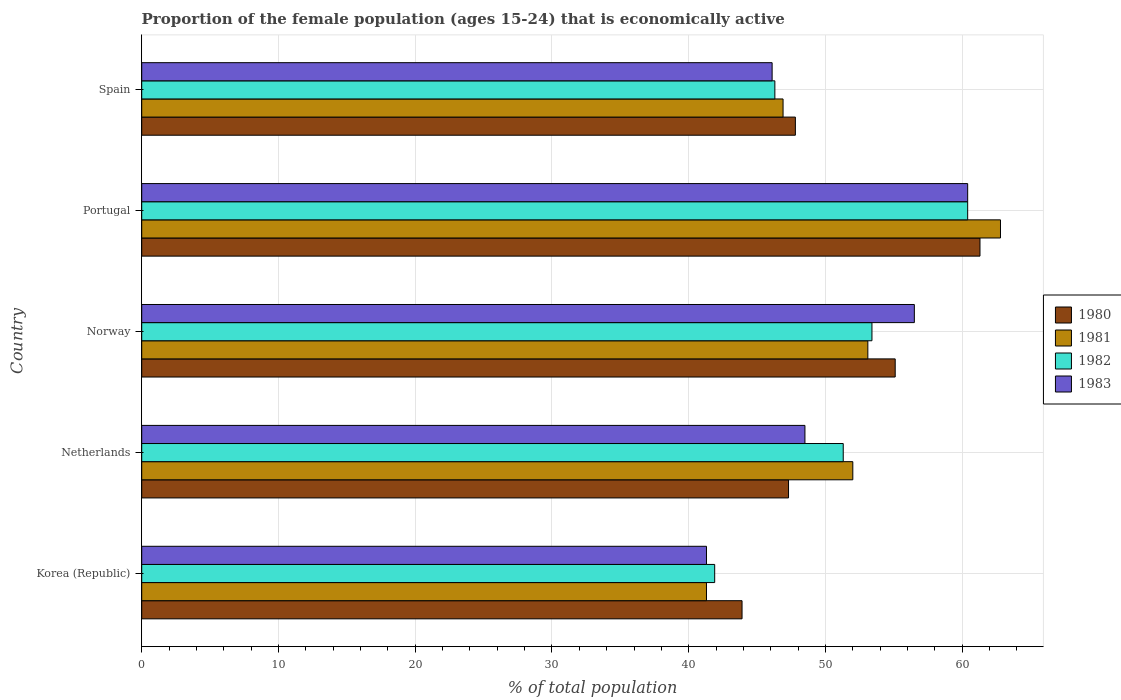How many different coloured bars are there?
Provide a short and direct response. 4. How many groups of bars are there?
Make the answer very short. 5. How many bars are there on the 5th tick from the bottom?
Offer a very short reply. 4. What is the label of the 5th group of bars from the top?
Ensure brevity in your answer.  Korea (Republic). In how many cases, is the number of bars for a given country not equal to the number of legend labels?
Give a very brief answer. 0. What is the proportion of the female population that is economically active in 1982 in Spain?
Provide a succinct answer. 46.3. Across all countries, what is the maximum proportion of the female population that is economically active in 1981?
Ensure brevity in your answer.  62.8. Across all countries, what is the minimum proportion of the female population that is economically active in 1983?
Provide a succinct answer. 41.3. In which country was the proportion of the female population that is economically active in 1982 maximum?
Offer a terse response. Portugal. What is the total proportion of the female population that is economically active in 1983 in the graph?
Keep it short and to the point. 252.8. What is the difference between the proportion of the female population that is economically active in 1983 in Netherlands and that in Spain?
Offer a very short reply. 2.4. What is the difference between the proportion of the female population that is economically active in 1983 in Portugal and the proportion of the female population that is economically active in 1980 in Spain?
Your answer should be very brief. 12.6. What is the average proportion of the female population that is economically active in 1982 per country?
Provide a short and direct response. 50.66. What is the difference between the proportion of the female population that is economically active in 1980 and proportion of the female population that is economically active in 1981 in Netherlands?
Provide a short and direct response. -4.7. In how many countries, is the proportion of the female population that is economically active in 1980 greater than 50 %?
Make the answer very short. 2. What is the ratio of the proportion of the female population that is economically active in 1983 in Norway to that in Spain?
Offer a terse response. 1.23. What is the difference between the highest and the second highest proportion of the female population that is economically active in 1980?
Make the answer very short. 6.2. What is the difference between the highest and the lowest proportion of the female population that is economically active in 1980?
Provide a succinct answer. 17.4. What does the 2nd bar from the top in Korea (Republic) represents?
Ensure brevity in your answer.  1982. What does the 2nd bar from the bottom in Netherlands represents?
Your answer should be very brief. 1981. Are all the bars in the graph horizontal?
Offer a terse response. Yes. How many countries are there in the graph?
Ensure brevity in your answer.  5. What is the difference between two consecutive major ticks on the X-axis?
Make the answer very short. 10. Where does the legend appear in the graph?
Your answer should be very brief. Center right. How are the legend labels stacked?
Offer a terse response. Vertical. What is the title of the graph?
Keep it short and to the point. Proportion of the female population (ages 15-24) that is economically active. What is the label or title of the X-axis?
Give a very brief answer. % of total population. What is the label or title of the Y-axis?
Your answer should be compact. Country. What is the % of total population of 1980 in Korea (Republic)?
Your answer should be very brief. 43.9. What is the % of total population of 1981 in Korea (Republic)?
Your answer should be very brief. 41.3. What is the % of total population in 1982 in Korea (Republic)?
Provide a short and direct response. 41.9. What is the % of total population of 1983 in Korea (Republic)?
Provide a succinct answer. 41.3. What is the % of total population in 1980 in Netherlands?
Keep it short and to the point. 47.3. What is the % of total population in 1981 in Netherlands?
Keep it short and to the point. 52. What is the % of total population of 1982 in Netherlands?
Keep it short and to the point. 51.3. What is the % of total population in 1983 in Netherlands?
Provide a succinct answer. 48.5. What is the % of total population in 1980 in Norway?
Your answer should be compact. 55.1. What is the % of total population of 1981 in Norway?
Your answer should be very brief. 53.1. What is the % of total population in 1982 in Norway?
Your answer should be very brief. 53.4. What is the % of total population in 1983 in Norway?
Provide a succinct answer. 56.5. What is the % of total population in 1980 in Portugal?
Give a very brief answer. 61.3. What is the % of total population in 1981 in Portugal?
Your answer should be compact. 62.8. What is the % of total population in 1982 in Portugal?
Provide a succinct answer. 60.4. What is the % of total population in 1983 in Portugal?
Give a very brief answer. 60.4. What is the % of total population in 1980 in Spain?
Your answer should be very brief. 47.8. What is the % of total population of 1981 in Spain?
Your response must be concise. 46.9. What is the % of total population in 1982 in Spain?
Ensure brevity in your answer.  46.3. What is the % of total population in 1983 in Spain?
Keep it short and to the point. 46.1. Across all countries, what is the maximum % of total population in 1980?
Offer a terse response. 61.3. Across all countries, what is the maximum % of total population in 1981?
Offer a very short reply. 62.8. Across all countries, what is the maximum % of total population of 1982?
Your response must be concise. 60.4. Across all countries, what is the maximum % of total population in 1983?
Make the answer very short. 60.4. Across all countries, what is the minimum % of total population of 1980?
Your response must be concise. 43.9. Across all countries, what is the minimum % of total population of 1981?
Your answer should be compact. 41.3. Across all countries, what is the minimum % of total population of 1982?
Ensure brevity in your answer.  41.9. Across all countries, what is the minimum % of total population in 1983?
Make the answer very short. 41.3. What is the total % of total population of 1980 in the graph?
Offer a terse response. 255.4. What is the total % of total population of 1981 in the graph?
Ensure brevity in your answer.  256.1. What is the total % of total population in 1982 in the graph?
Make the answer very short. 253.3. What is the total % of total population in 1983 in the graph?
Your response must be concise. 252.8. What is the difference between the % of total population of 1980 in Korea (Republic) and that in Netherlands?
Your response must be concise. -3.4. What is the difference between the % of total population of 1981 in Korea (Republic) and that in Netherlands?
Give a very brief answer. -10.7. What is the difference between the % of total population in 1982 in Korea (Republic) and that in Netherlands?
Your response must be concise. -9.4. What is the difference between the % of total population of 1983 in Korea (Republic) and that in Netherlands?
Your answer should be very brief. -7.2. What is the difference between the % of total population of 1981 in Korea (Republic) and that in Norway?
Give a very brief answer. -11.8. What is the difference between the % of total population in 1983 in Korea (Republic) and that in Norway?
Make the answer very short. -15.2. What is the difference between the % of total population in 1980 in Korea (Republic) and that in Portugal?
Provide a short and direct response. -17.4. What is the difference between the % of total population of 1981 in Korea (Republic) and that in Portugal?
Keep it short and to the point. -21.5. What is the difference between the % of total population in 1982 in Korea (Republic) and that in Portugal?
Provide a succinct answer. -18.5. What is the difference between the % of total population of 1983 in Korea (Republic) and that in Portugal?
Your answer should be compact. -19.1. What is the difference between the % of total population in 1980 in Korea (Republic) and that in Spain?
Ensure brevity in your answer.  -3.9. What is the difference between the % of total population of 1982 in Korea (Republic) and that in Spain?
Offer a very short reply. -4.4. What is the difference between the % of total population in 1983 in Korea (Republic) and that in Spain?
Keep it short and to the point. -4.8. What is the difference between the % of total population in 1981 in Netherlands and that in Norway?
Your response must be concise. -1.1. What is the difference between the % of total population of 1982 in Netherlands and that in Norway?
Your answer should be very brief. -2.1. What is the difference between the % of total population in 1980 in Netherlands and that in Portugal?
Ensure brevity in your answer.  -14. What is the difference between the % of total population of 1980 in Netherlands and that in Spain?
Your answer should be compact. -0.5. What is the difference between the % of total population in 1981 in Netherlands and that in Spain?
Provide a short and direct response. 5.1. What is the difference between the % of total population in 1983 in Netherlands and that in Spain?
Make the answer very short. 2.4. What is the difference between the % of total population of 1982 in Norway and that in Portugal?
Your answer should be compact. -7. What is the difference between the % of total population in 1983 in Norway and that in Portugal?
Make the answer very short. -3.9. What is the difference between the % of total population in 1981 in Norway and that in Spain?
Offer a terse response. 6.2. What is the difference between the % of total population in 1980 in Portugal and that in Spain?
Ensure brevity in your answer.  13.5. What is the difference between the % of total population of 1981 in Portugal and that in Spain?
Give a very brief answer. 15.9. What is the difference between the % of total population in 1982 in Portugal and that in Spain?
Your response must be concise. 14.1. What is the difference between the % of total population of 1983 in Portugal and that in Spain?
Make the answer very short. 14.3. What is the difference between the % of total population of 1980 in Korea (Republic) and the % of total population of 1981 in Netherlands?
Make the answer very short. -8.1. What is the difference between the % of total population of 1980 in Korea (Republic) and the % of total population of 1982 in Netherlands?
Give a very brief answer. -7.4. What is the difference between the % of total population of 1980 in Korea (Republic) and the % of total population of 1983 in Netherlands?
Keep it short and to the point. -4.6. What is the difference between the % of total population in 1980 in Korea (Republic) and the % of total population in 1981 in Norway?
Your answer should be compact. -9.2. What is the difference between the % of total population in 1980 in Korea (Republic) and the % of total population in 1983 in Norway?
Offer a terse response. -12.6. What is the difference between the % of total population of 1981 in Korea (Republic) and the % of total population of 1983 in Norway?
Make the answer very short. -15.2. What is the difference between the % of total population of 1982 in Korea (Republic) and the % of total population of 1983 in Norway?
Ensure brevity in your answer.  -14.6. What is the difference between the % of total population of 1980 in Korea (Republic) and the % of total population of 1981 in Portugal?
Your answer should be very brief. -18.9. What is the difference between the % of total population in 1980 in Korea (Republic) and the % of total population in 1982 in Portugal?
Give a very brief answer. -16.5. What is the difference between the % of total population in 1980 in Korea (Republic) and the % of total population in 1983 in Portugal?
Your answer should be compact. -16.5. What is the difference between the % of total population in 1981 in Korea (Republic) and the % of total population in 1982 in Portugal?
Give a very brief answer. -19.1. What is the difference between the % of total population of 1981 in Korea (Republic) and the % of total population of 1983 in Portugal?
Keep it short and to the point. -19.1. What is the difference between the % of total population in 1982 in Korea (Republic) and the % of total population in 1983 in Portugal?
Keep it short and to the point. -18.5. What is the difference between the % of total population in 1981 in Korea (Republic) and the % of total population in 1982 in Spain?
Your answer should be very brief. -5. What is the difference between the % of total population of 1982 in Korea (Republic) and the % of total population of 1983 in Spain?
Ensure brevity in your answer.  -4.2. What is the difference between the % of total population in 1980 in Netherlands and the % of total population in 1982 in Norway?
Provide a succinct answer. -6.1. What is the difference between the % of total population in 1980 in Netherlands and the % of total population in 1983 in Norway?
Ensure brevity in your answer.  -9.2. What is the difference between the % of total population of 1980 in Netherlands and the % of total population of 1981 in Portugal?
Provide a succinct answer. -15.5. What is the difference between the % of total population of 1980 in Netherlands and the % of total population of 1982 in Portugal?
Keep it short and to the point. -13.1. What is the difference between the % of total population in 1980 in Netherlands and the % of total population in 1983 in Portugal?
Provide a succinct answer. -13.1. What is the difference between the % of total population in 1981 in Netherlands and the % of total population in 1982 in Portugal?
Keep it short and to the point. -8.4. What is the difference between the % of total population in 1981 in Netherlands and the % of total population in 1983 in Portugal?
Give a very brief answer. -8.4. What is the difference between the % of total population in 1980 in Netherlands and the % of total population in 1983 in Spain?
Provide a short and direct response. 1.2. What is the difference between the % of total population of 1981 in Netherlands and the % of total population of 1982 in Spain?
Provide a succinct answer. 5.7. What is the difference between the % of total population of 1980 in Norway and the % of total population of 1983 in Portugal?
Your answer should be compact. -5.3. What is the difference between the % of total population in 1981 in Norway and the % of total population in 1983 in Portugal?
Provide a short and direct response. -7.3. What is the difference between the % of total population in 1980 in Norway and the % of total population in 1983 in Spain?
Keep it short and to the point. 9. What is the difference between the % of total population in 1981 in Norway and the % of total population in 1983 in Spain?
Your answer should be very brief. 7. What is the difference between the % of total population of 1980 in Portugal and the % of total population of 1981 in Spain?
Offer a terse response. 14.4. What is the difference between the % of total population of 1981 in Portugal and the % of total population of 1982 in Spain?
Provide a succinct answer. 16.5. What is the average % of total population in 1980 per country?
Offer a terse response. 51.08. What is the average % of total population of 1981 per country?
Your answer should be very brief. 51.22. What is the average % of total population in 1982 per country?
Your answer should be compact. 50.66. What is the average % of total population of 1983 per country?
Offer a terse response. 50.56. What is the difference between the % of total population of 1980 and % of total population of 1983 in Korea (Republic)?
Make the answer very short. 2.6. What is the difference between the % of total population of 1980 and % of total population of 1981 in Netherlands?
Your response must be concise. -4.7. What is the difference between the % of total population of 1981 and % of total population of 1982 in Netherlands?
Your response must be concise. 0.7. What is the difference between the % of total population of 1980 and % of total population of 1982 in Norway?
Give a very brief answer. 1.7. What is the difference between the % of total population in 1980 and % of total population in 1983 in Norway?
Ensure brevity in your answer.  -1.4. What is the difference between the % of total population of 1981 and % of total population of 1983 in Norway?
Provide a short and direct response. -3.4. What is the difference between the % of total population of 1980 and % of total population of 1983 in Portugal?
Your answer should be compact. 0.9. What is the difference between the % of total population of 1980 and % of total population of 1981 in Spain?
Give a very brief answer. 0.9. What is the difference between the % of total population in 1980 and % of total population in 1982 in Spain?
Ensure brevity in your answer.  1.5. What is the difference between the % of total population of 1981 and % of total population of 1982 in Spain?
Give a very brief answer. 0.6. What is the difference between the % of total population of 1982 and % of total population of 1983 in Spain?
Give a very brief answer. 0.2. What is the ratio of the % of total population in 1980 in Korea (Republic) to that in Netherlands?
Offer a very short reply. 0.93. What is the ratio of the % of total population in 1981 in Korea (Republic) to that in Netherlands?
Give a very brief answer. 0.79. What is the ratio of the % of total population in 1982 in Korea (Republic) to that in Netherlands?
Your answer should be compact. 0.82. What is the ratio of the % of total population of 1983 in Korea (Republic) to that in Netherlands?
Offer a terse response. 0.85. What is the ratio of the % of total population of 1980 in Korea (Republic) to that in Norway?
Provide a succinct answer. 0.8. What is the ratio of the % of total population in 1982 in Korea (Republic) to that in Norway?
Give a very brief answer. 0.78. What is the ratio of the % of total population in 1983 in Korea (Republic) to that in Norway?
Give a very brief answer. 0.73. What is the ratio of the % of total population in 1980 in Korea (Republic) to that in Portugal?
Make the answer very short. 0.72. What is the ratio of the % of total population of 1981 in Korea (Republic) to that in Portugal?
Keep it short and to the point. 0.66. What is the ratio of the % of total population in 1982 in Korea (Republic) to that in Portugal?
Offer a terse response. 0.69. What is the ratio of the % of total population of 1983 in Korea (Republic) to that in Portugal?
Your answer should be very brief. 0.68. What is the ratio of the % of total population of 1980 in Korea (Republic) to that in Spain?
Give a very brief answer. 0.92. What is the ratio of the % of total population of 1981 in Korea (Republic) to that in Spain?
Your answer should be very brief. 0.88. What is the ratio of the % of total population of 1982 in Korea (Republic) to that in Spain?
Ensure brevity in your answer.  0.91. What is the ratio of the % of total population of 1983 in Korea (Republic) to that in Spain?
Ensure brevity in your answer.  0.9. What is the ratio of the % of total population in 1980 in Netherlands to that in Norway?
Your answer should be very brief. 0.86. What is the ratio of the % of total population in 1981 in Netherlands to that in Norway?
Offer a very short reply. 0.98. What is the ratio of the % of total population of 1982 in Netherlands to that in Norway?
Offer a terse response. 0.96. What is the ratio of the % of total population of 1983 in Netherlands to that in Norway?
Your answer should be very brief. 0.86. What is the ratio of the % of total population in 1980 in Netherlands to that in Portugal?
Make the answer very short. 0.77. What is the ratio of the % of total population of 1981 in Netherlands to that in Portugal?
Your answer should be compact. 0.83. What is the ratio of the % of total population in 1982 in Netherlands to that in Portugal?
Your answer should be very brief. 0.85. What is the ratio of the % of total population in 1983 in Netherlands to that in Portugal?
Offer a very short reply. 0.8. What is the ratio of the % of total population in 1980 in Netherlands to that in Spain?
Your response must be concise. 0.99. What is the ratio of the % of total population in 1981 in Netherlands to that in Spain?
Keep it short and to the point. 1.11. What is the ratio of the % of total population in 1982 in Netherlands to that in Spain?
Offer a very short reply. 1.11. What is the ratio of the % of total population of 1983 in Netherlands to that in Spain?
Make the answer very short. 1.05. What is the ratio of the % of total population in 1980 in Norway to that in Portugal?
Give a very brief answer. 0.9. What is the ratio of the % of total population in 1981 in Norway to that in Portugal?
Your response must be concise. 0.85. What is the ratio of the % of total population in 1982 in Norway to that in Portugal?
Your answer should be compact. 0.88. What is the ratio of the % of total population of 1983 in Norway to that in Portugal?
Your answer should be very brief. 0.94. What is the ratio of the % of total population of 1980 in Norway to that in Spain?
Give a very brief answer. 1.15. What is the ratio of the % of total population in 1981 in Norway to that in Spain?
Make the answer very short. 1.13. What is the ratio of the % of total population in 1982 in Norway to that in Spain?
Your answer should be compact. 1.15. What is the ratio of the % of total population in 1983 in Norway to that in Spain?
Keep it short and to the point. 1.23. What is the ratio of the % of total population in 1980 in Portugal to that in Spain?
Provide a succinct answer. 1.28. What is the ratio of the % of total population in 1981 in Portugal to that in Spain?
Provide a short and direct response. 1.34. What is the ratio of the % of total population of 1982 in Portugal to that in Spain?
Your response must be concise. 1.3. What is the ratio of the % of total population in 1983 in Portugal to that in Spain?
Offer a very short reply. 1.31. What is the difference between the highest and the second highest % of total population of 1981?
Offer a terse response. 9.7. What is the difference between the highest and the second highest % of total population of 1982?
Your answer should be compact. 7. What is the difference between the highest and the second highest % of total population of 1983?
Ensure brevity in your answer.  3.9. What is the difference between the highest and the lowest % of total population of 1980?
Your answer should be compact. 17.4. What is the difference between the highest and the lowest % of total population of 1981?
Provide a succinct answer. 21.5. 